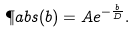Convert formula to latex. <formula><loc_0><loc_0><loc_500><loc_500>\P a b s ( b ) = A e ^ { - \frac { b } { \L D } } .</formula> 